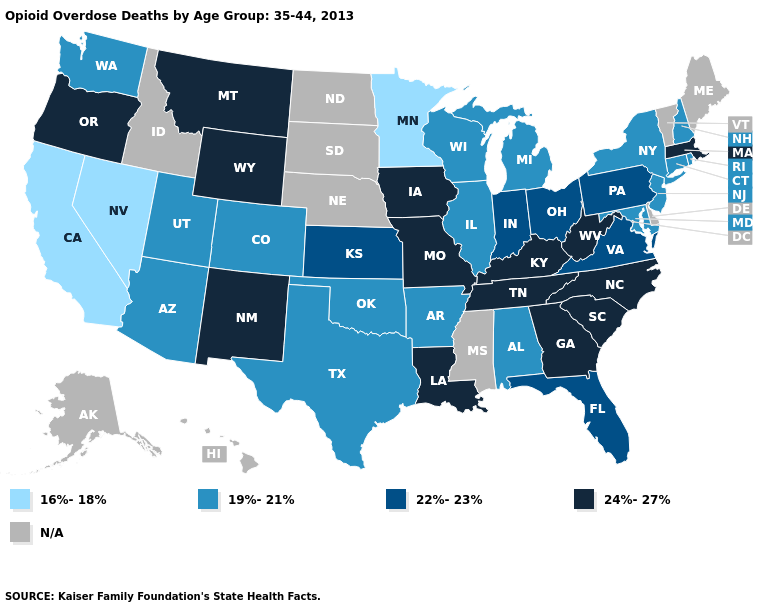What is the lowest value in states that border Idaho?
Give a very brief answer. 16%-18%. Name the states that have a value in the range 24%-27%?
Be succinct. Georgia, Iowa, Kentucky, Louisiana, Massachusetts, Missouri, Montana, New Mexico, North Carolina, Oregon, South Carolina, Tennessee, West Virginia, Wyoming. Name the states that have a value in the range 16%-18%?
Short answer required. California, Minnesota, Nevada. Does Kentucky have the highest value in the USA?
Be succinct. Yes. What is the value of New Mexico?
Keep it brief. 24%-27%. Which states hav the highest value in the South?
Be succinct. Georgia, Kentucky, Louisiana, North Carolina, South Carolina, Tennessee, West Virginia. Name the states that have a value in the range 19%-21%?
Short answer required. Alabama, Arizona, Arkansas, Colorado, Connecticut, Illinois, Maryland, Michigan, New Hampshire, New Jersey, New York, Oklahoma, Rhode Island, Texas, Utah, Washington, Wisconsin. Does California have the lowest value in the West?
Give a very brief answer. Yes. What is the highest value in the USA?
Answer briefly. 24%-27%. Which states have the lowest value in the West?
Be succinct. California, Nevada. What is the lowest value in the USA?
Write a very short answer. 16%-18%. Name the states that have a value in the range 24%-27%?
Concise answer only. Georgia, Iowa, Kentucky, Louisiana, Massachusetts, Missouri, Montana, New Mexico, North Carolina, Oregon, South Carolina, Tennessee, West Virginia, Wyoming. 